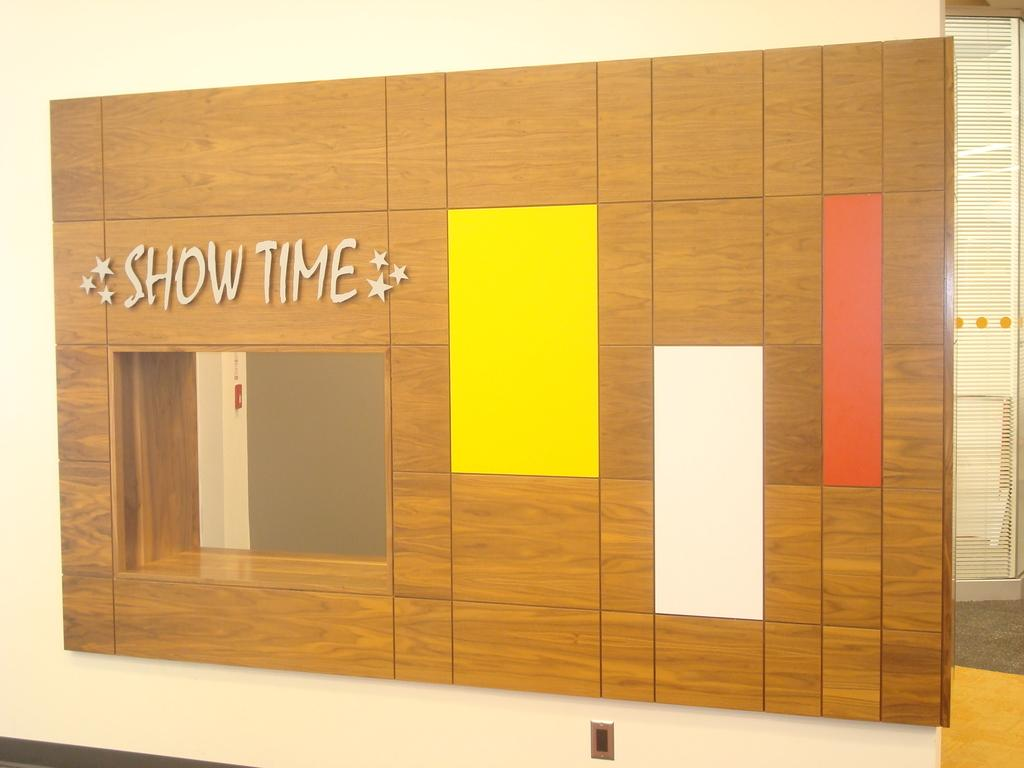What is attached to the wall in the image? There is a board on a wall in the image. What can be seen through the window in the image? The image does not show what can be seen through the window. What is written or displayed on the board? There is some text visible in the image on the board. What architectural feature is visible in the background of the image? There is a door in the background of the image. What is at the bottom of the image? There is a floor at the bottom of the image. What is the chance of sleet falling in the image? There is no information about weather conditions in the image, so it is impossible to determine the chance of sleet falling. 